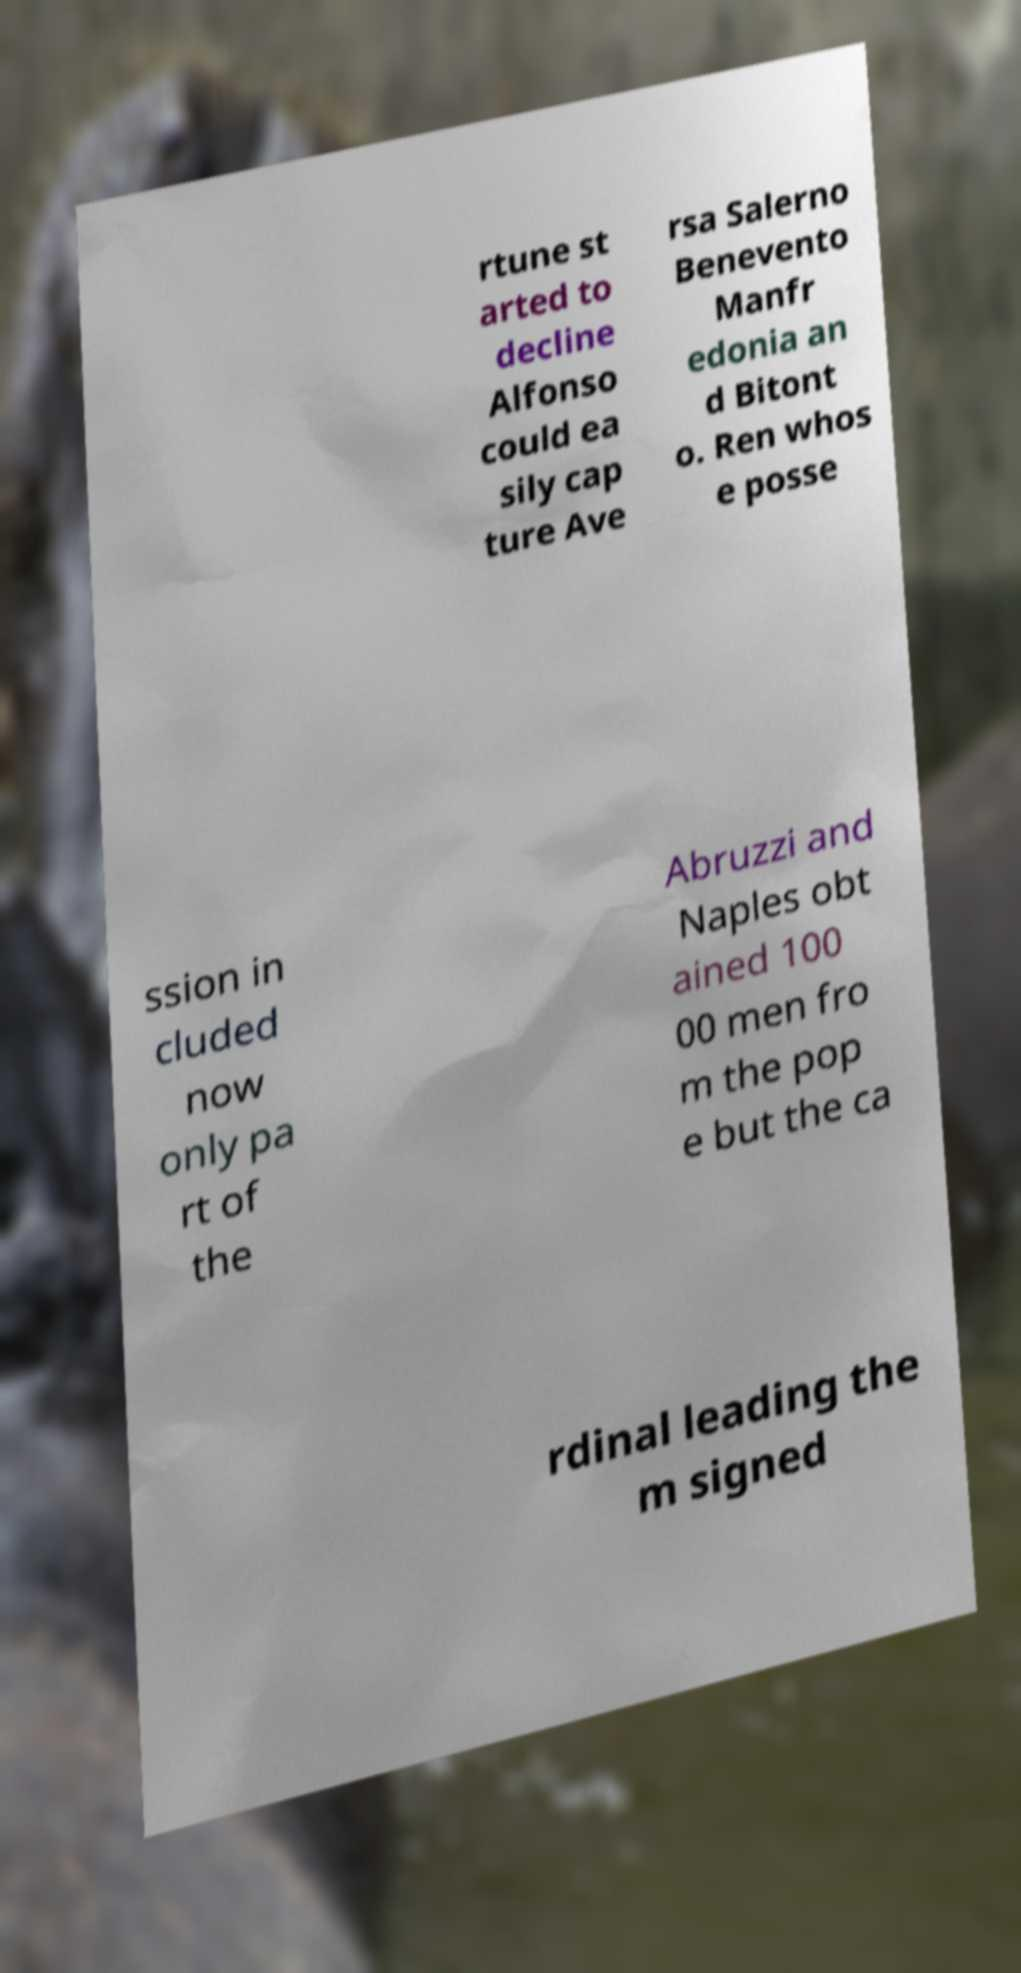For documentation purposes, I need the text within this image transcribed. Could you provide that? rtune st arted to decline Alfonso could ea sily cap ture Ave rsa Salerno Benevento Manfr edonia an d Bitont o. Ren whos e posse ssion in cluded now only pa rt of the Abruzzi and Naples obt ained 100 00 men fro m the pop e but the ca rdinal leading the m signed 